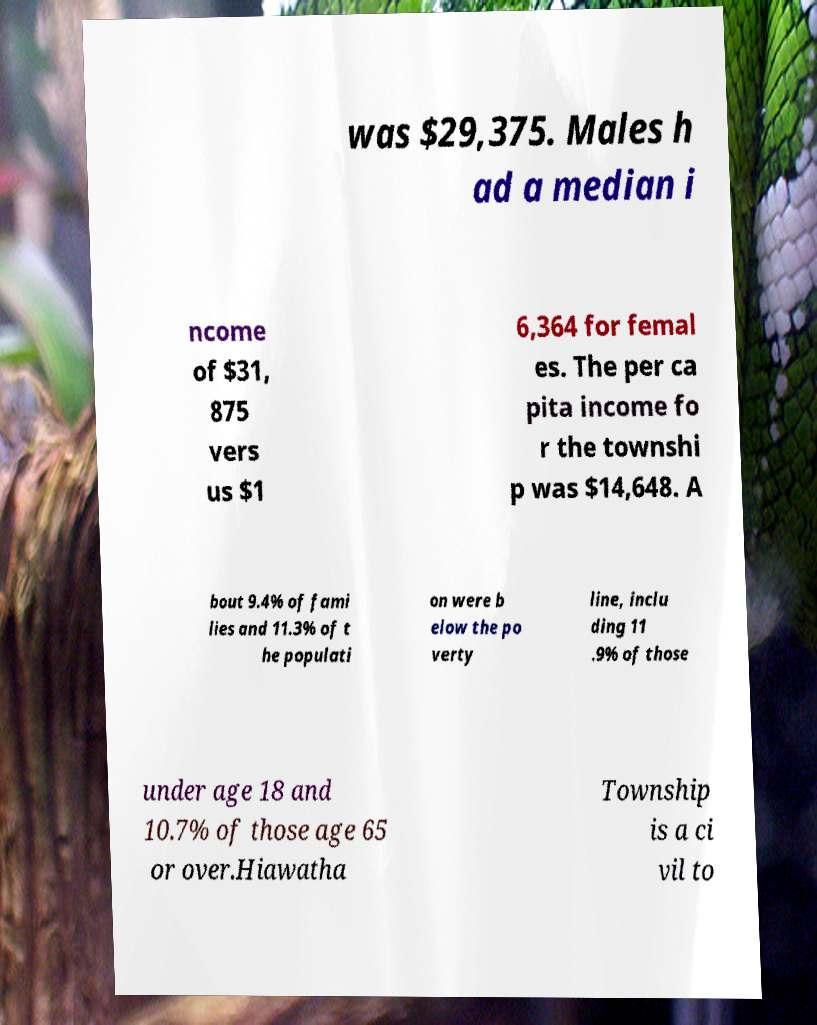Could you extract and type out the text from this image? was $29,375. Males h ad a median i ncome of $31, 875 vers us $1 6,364 for femal es. The per ca pita income fo r the townshi p was $14,648. A bout 9.4% of fami lies and 11.3% of t he populati on were b elow the po verty line, inclu ding 11 .9% of those under age 18 and 10.7% of those age 65 or over.Hiawatha Township is a ci vil to 